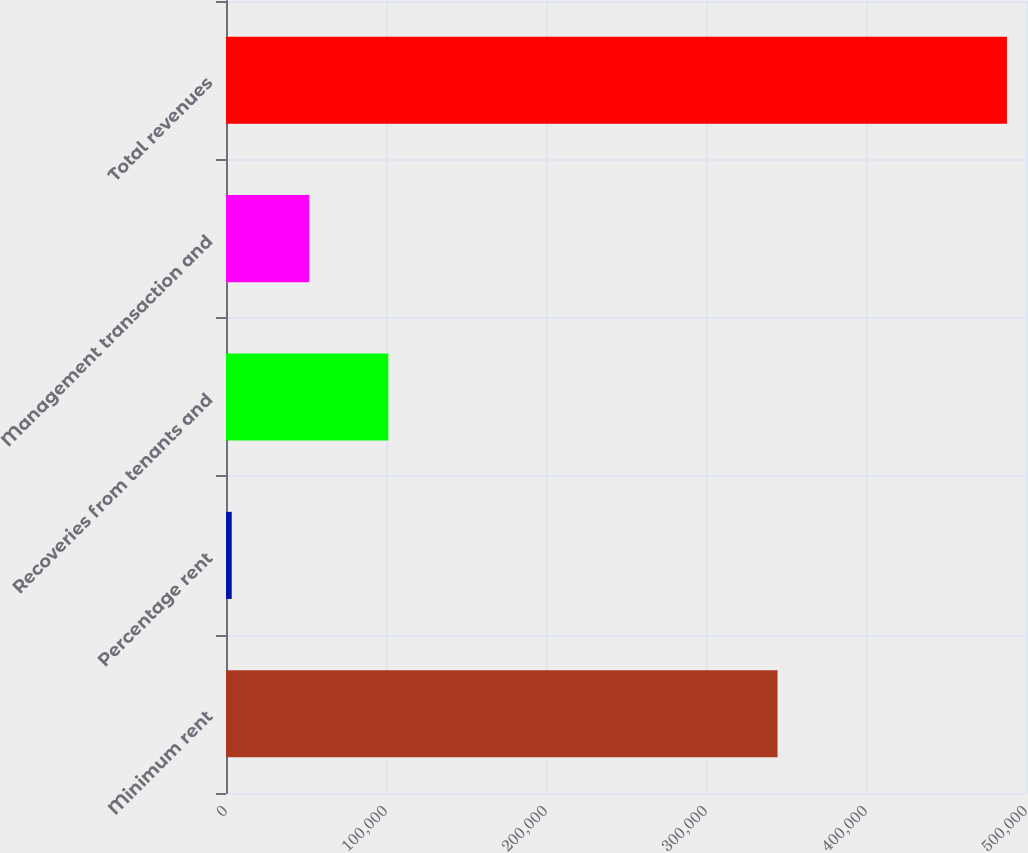Convert chart. <chart><loc_0><loc_0><loc_500><loc_500><bar_chart><fcel>Minimum rent<fcel>Percentage rent<fcel>Recoveries from tenants and<fcel>Management transaction and<fcel>Total revenues<nl><fcel>344709<fcel>3585<fcel>101490<fcel>52033.8<fcel>488073<nl></chart> 